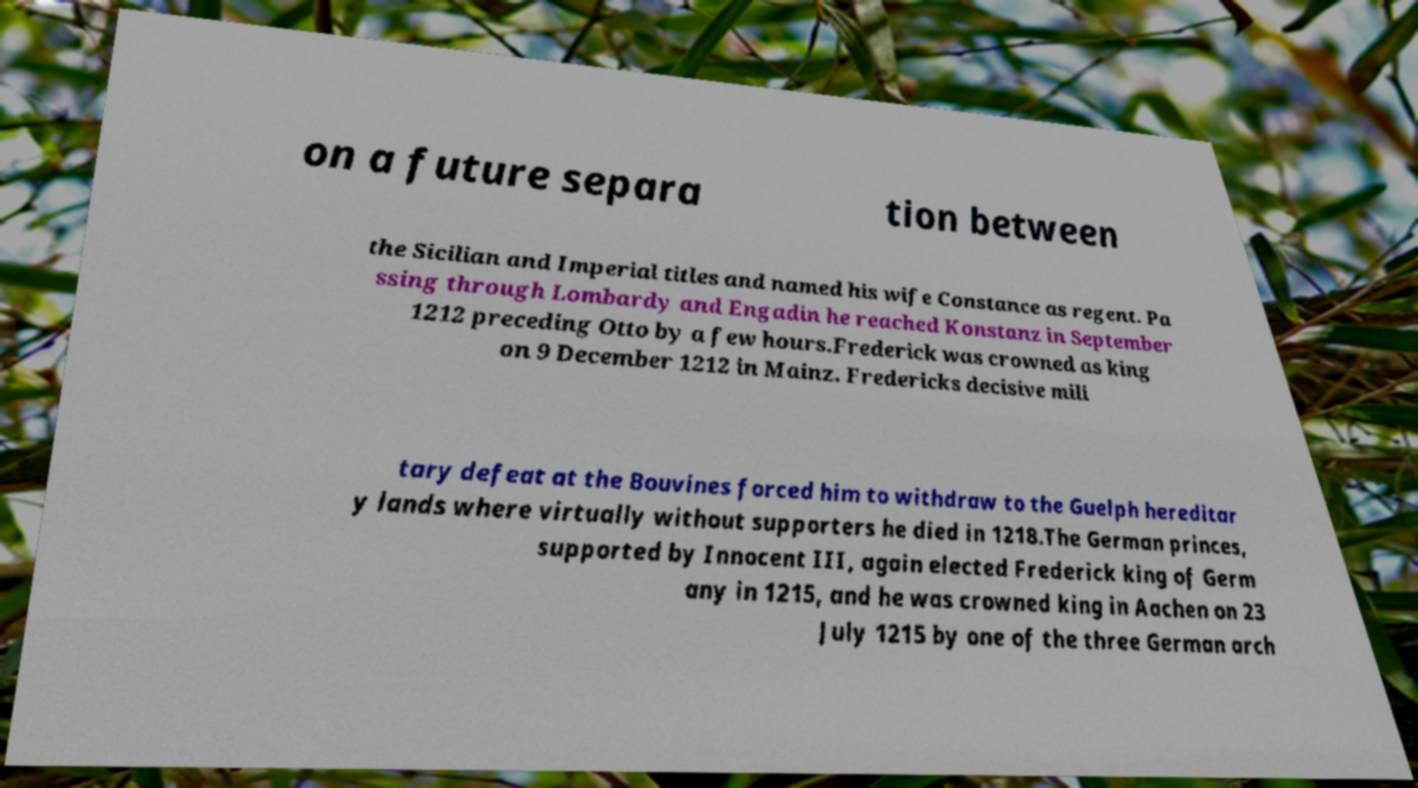For documentation purposes, I need the text within this image transcribed. Could you provide that? on a future separa tion between the Sicilian and Imperial titles and named his wife Constance as regent. Pa ssing through Lombardy and Engadin he reached Konstanz in September 1212 preceding Otto by a few hours.Frederick was crowned as king on 9 December 1212 in Mainz. Fredericks decisive mili tary defeat at the Bouvines forced him to withdraw to the Guelph hereditar y lands where virtually without supporters he died in 1218.The German princes, supported by Innocent III, again elected Frederick king of Germ any in 1215, and he was crowned king in Aachen on 23 July 1215 by one of the three German arch 